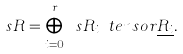<formula> <loc_0><loc_0><loc_500><loc_500>\ s R = \bigoplus _ { i = 0 } ^ { r } \ s R _ { i } \ t e n s o r \underline { R _ { i } } .</formula> 